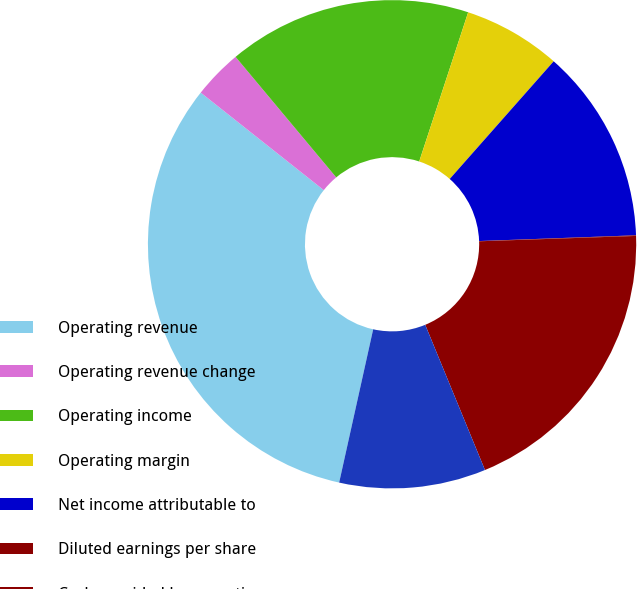Convert chart. <chart><loc_0><loc_0><loc_500><loc_500><pie_chart><fcel>Operating revenue<fcel>Operating revenue change<fcel>Operating income<fcel>Operating margin<fcel>Net income attributable to<fcel>Diluted earnings per share<fcel>Cash provided by operating<fcel>Capital expenditures<nl><fcel>32.19%<fcel>3.26%<fcel>16.12%<fcel>6.47%<fcel>12.9%<fcel>0.04%<fcel>19.33%<fcel>9.69%<nl></chart> 